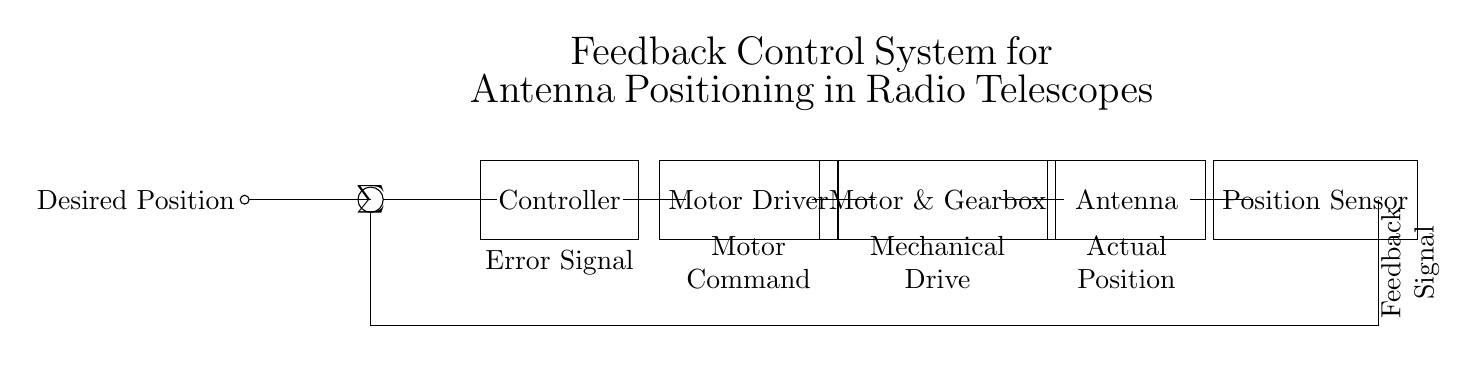What is the main function of the controller in this circuit? The controller processes the error signal, which is the difference between the desired position and the actual position, and generates an output to correct the position of the antenna.
Answer: Position correction What component is responsible for driving the motor? The motor driver receives commands from the controller and supplies the necessary power and control signals to the motor for movement.
Answer: Motor Driver What is the purpose of the position sensor? The position sensor monitors the actual position of the antenna and provides feedback to the controller to ensure accurate positioning.
Answer: Feedback What type of control system is represented in this diagram? This is a feedback control system as it utilizes a continuous feedback loop from the position sensor to adjust the antenna's position.
Answer: Feedback control What is the relationship between desired position and actual position in this circuit? The desired position is compared to the actual position; any difference (error) is used by the controller to adjust the motor's command for positioning corrections.
Answer: Error signal How does the feedback loop operate in this system? The feedback loop involves the position sensor providing the actual position back to the summation point, which, along with the desired position, generates the error signal for correction.
Answer: Continuous adjustment What is the sequence of operations from desired position to antenna position? Desired position is input to the summation point, the error signal is generated, the controller processes it, the motor driver executes the command, and finally, the motor moves the antenna to the actual position.
Answer: Desired to actual 